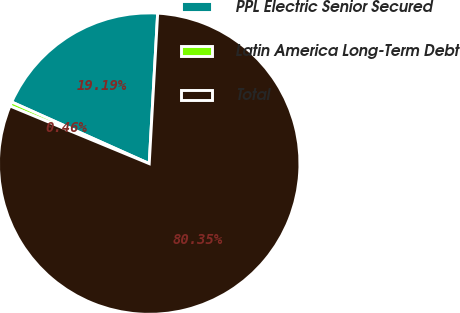Convert chart to OTSL. <chart><loc_0><loc_0><loc_500><loc_500><pie_chart><fcel>PPL Electric Senior Secured<fcel>Latin America Long-Term Debt<fcel>Total<nl><fcel>19.19%<fcel>0.46%<fcel>80.35%<nl></chart> 